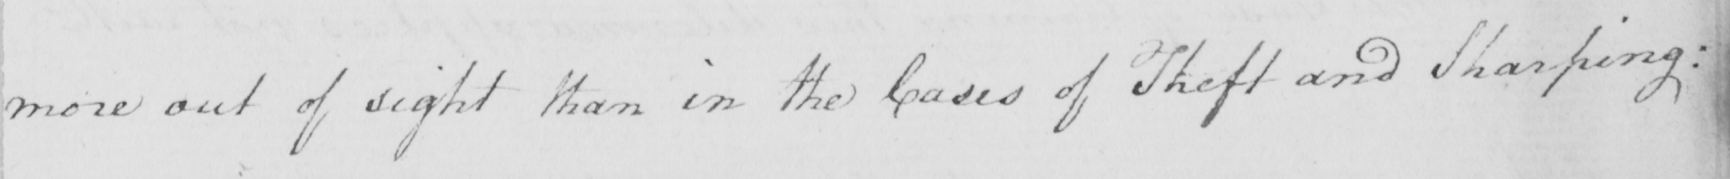What does this handwritten line say? more out of sight than in the Cases of Theft and Sharping : 